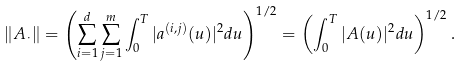Convert formula to latex. <formula><loc_0><loc_0><loc_500><loc_500>\| A _ { \cdot } \| = \left ( \sum _ { i = 1 } ^ { d } \sum _ { j = 1 } ^ { m } \int _ { 0 } ^ { T } | a ^ { ( i , j ) } ( u ) | ^ { 2 } d u \right ) ^ { 1 / 2 } = \left ( \int _ { 0 } ^ { T } | A ( u ) | ^ { 2 } d u \right ) ^ { 1 / 2 } .</formula> 